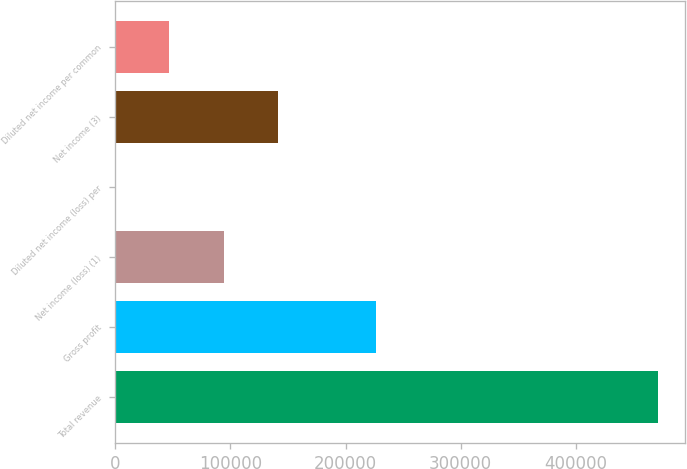<chart> <loc_0><loc_0><loc_500><loc_500><bar_chart><fcel>Total revenue<fcel>Gross profit<fcel>Net income (loss) (1)<fcel>Diluted net income (loss) per<fcel>Net income (3)<fcel>Diluted net income per common<nl><fcel>471165<fcel>226110<fcel>94233.1<fcel>0.15<fcel>141350<fcel>47116.6<nl></chart> 